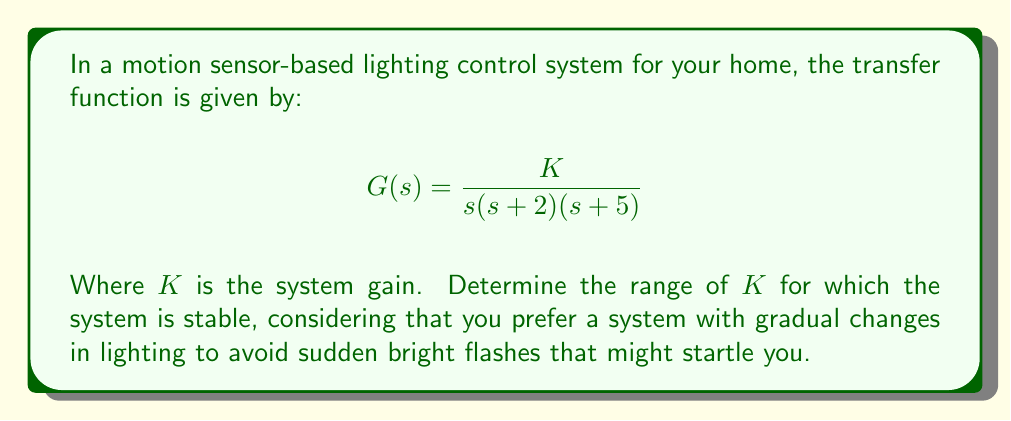Show me your answer to this math problem. To determine the range of $K$ for system stability, we need to analyze the root locus plot. Let's follow these steps:

1. Identify the open-loop poles:
   The poles are at $s = 0$, $s = -2$, and $s = -5$

2. Calculate the centroid:
   $$\text{Centroid} = \frac{0 + (-2) + (-5)}{3} = -\frac{7}{3}$$

3. Calculate the asymptote angles:
   $$\theta = \frac{(2k+1)\pi}{n-m}$$
   Where $n = 3$ (number of poles) and $m = 0$ (number of zeros)
   $$\theta = \frac{(2k+1)\pi}{3}, \text{ for } k = 0, 1, 2$$
   $$\theta = 60°, 180°, 300°$$

4. Find the breakaway point:
   The breakaway point occurs on the real axis between $s = -2$ and $s = -5$
   Let $s = -x$
   $$\frac{d}{ds}\left(\frac{1}{s(s+2)(s+5)}\right) = 0$$
   Solving this equation yields $x \approx 3.17$

5. Calculate the root locus gain at the imaginary axis crossing:
   Use the Routh-Hurwitz criterion:
   $$s^3 + 7s^2 + 10s + K = 0$$
   The system becomes unstable when $K = 70$

For stability, we need $0 < K < 70$. However, considering the persona's preference for gradual changes, we should choose a lower value of $K$ within this range to ensure smoother transitions in lighting.
Answer: The system is stable for $0 < K < 70$. For smoother lighting transitions, choose $K$ in the lower part of this range, e.g., $10 < K < 30$. 